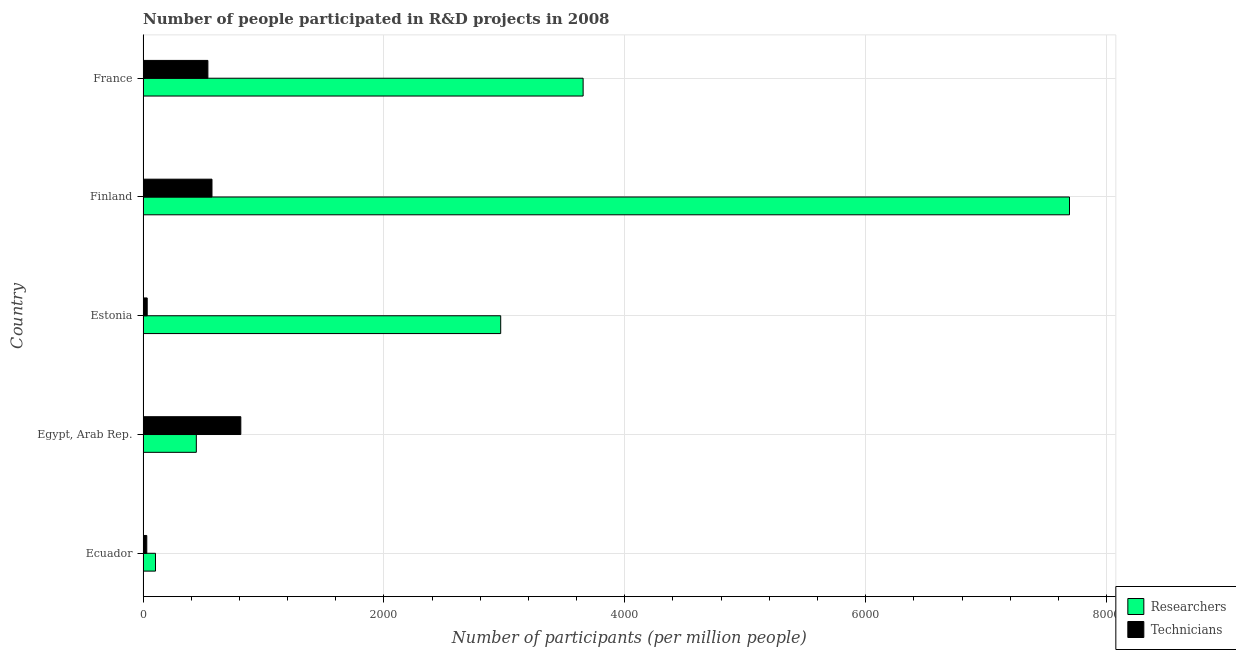How many groups of bars are there?
Give a very brief answer. 5. Are the number of bars on each tick of the Y-axis equal?
Ensure brevity in your answer.  Yes. How many bars are there on the 1st tick from the top?
Ensure brevity in your answer.  2. How many bars are there on the 2nd tick from the bottom?
Give a very brief answer. 2. What is the label of the 4th group of bars from the top?
Make the answer very short. Egypt, Arab Rep. What is the number of technicians in Finland?
Offer a terse response. 572.24. Across all countries, what is the maximum number of technicians?
Provide a short and direct response. 811.65. Across all countries, what is the minimum number of technicians?
Your answer should be compact. 30.85. In which country was the number of researchers minimum?
Your response must be concise. Ecuador. What is the total number of researchers in the graph?
Provide a succinct answer. 1.49e+04. What is the difference between the number of technicians in Egypt, Arab Rep. and that in Finland?
Give a very brief answer. 239.41. What is the difference between the number of technicians in Ecuador and the number of researchers in Finland?
Your answer should be compact. -7661.59. What is the average number of researchers per country?
Offer a terse response. 2972.29. What is the difference between the number of researchers and number of technicians in France?
Your answer should be compact. 3115.76. What is the ratio of the number of researchers in Estonia to that in Finland?
Offer a terse response. 0.39. Is the number of technicians in Egypt, Arab Rep. less than that in Finland?
Give a very brief answer. No. What is the difference between the highest and the second highest number of technicians?
Give a very brief answer. 239.41. What is the difference between the highest and the lowest number of technicians?
Offer a very short reply. 780.8. In how many countries, is the number of researchers greater than the average number of researchers taken over all countries?
Your answer should be very brief. 2. Is the sum of the number of technicians in Estonia and Finland greater than the maximum number of researchers across all countries?
Make the answer very short. No. What does the 1st bar from the top in France represents?
Ensure brevity in your answer.  Technicians. What does the 2nd bar from the bottom in Finland represents?
Your response must be concise. Technicians. Are all the bars in the graph horizontal?
Keep it short and to the point. Yes. What is the difference between two consecutive major ticks on the X-axis?
Make the answer very short. 2000. Are the values on the major ticks of X-axis written in scientific E-notation?
Keep it short and to the point. No. Does the graph contain grids?
Give a very brief answer. Yes. What is the title of the graph?
Provide a short and direct response. Number of people participated in R&D projects in 2008. What is the label or title of the X-axis?
Offer a very short reply. Number of participants (per million people). What is the Number of participants (per million people) in Researchers in Ecuador?
Your answer should be compact. 103.23. What is the Number of participants (per million people) of Technicians in Ecuador?
Make the answer very short. 30.85. What is the Number of participants (per million people) of Researchers in Egypt, Arab Rep.?
Your answer should be compact. 442.27. What is the Number of participants (per million people) in Technicians in Egypt, Arab Rep.?
Provide a succinct answer. 811.65. What is the Number of participants (per million people) in Researchers in Estonia?
Your response must be concise. 2969.53. What is the Number of participants (per million people) of Technicians in Estonia?
Offer a very short reply. 34.38. What is the Number of participants (per million people) in Researchers in Finland?
Keep it short and to the point. 7692.44. What is the Number of participants (per million people) of Technicians in Finland?
Offer a very short reply. 572.24. What is the Number of participants (per million people) in Researchers in France?
Your answer should be very brief. 3653.99. What is the Number of participants (per million people) of Technicians in France?
Your response must be concise. 538.23. Across all countries, what is the maximum Number of participants (per million people) in Researchers?
Your response must be concise. 7692.44. Across all countries, what is the maximum Number of participants (per million people) in Technicians?
Keep it short and to the point. 811.65. Across all countries, what is the minimum Number of participants (per million people) of Researchers?
Keep it short and to the point. 103.23. Across all countries, what is the minimum Number of participants (per million people) in Technicians?
Provide a succinct answer. 30.85. What is the total Number of participants (per million people) of Researchers in the graph?
Offer a very short reply. 1.49e+04. What is the total Number of participants (per million people) of Technicians in the graph?
Make the answer very short. 1987.34. What is the difference between the Number of participants (per million people) in Researchers in Ecuador and that in Egypt, Arab Rep.?
Provide a short and direct response. -339.04. What is the difference between the Number of participants (per million people) of Technicians in Ecuador and that in Egypt, Arab Rep.?
Ensure brevity in your answer.  -780.8. What is the difference between the Number of participants (per million people) of Researchers in Ecuador and that in Estonia?
Make the answer very short. -2866.3. What is the difference between the Number of participants (per million people) of Technicians in Ecuador and that in Estonia?
Ensure brevity in your answer.  -3.53. What is the difference between the Number of participants (per million people) of Researchers in Ecuador and that in Finland?
Ensure brevity in your answer.  -7589.21. What is the difference between the Number of participants (per million people) of Technicians in Ecuador and that in Finland?
Your answer should be very brief. -541.39. What is the difference between the Number of participants (per million people) in Researchers in Ecuador and that in France?
Provide a succinct answer. -3550.76. What is the difference between the Number of participants (per million people) in Technicians in Ecuador and that in France?
Offer a terse response. -507.38. What is the difference between the Number of participants (per million people) in Researchers in Egypt, Arab Rep. and that in Estonia?
Give a very brief answer. -2527.26. What is the difference between the Number of participants (per million people) of Technicians in Egypt, Arab Rep. and that in Estonia?
Your response must be concise. 777.27. What is the difference between the Number of participants (per million people) in Researchers in Egypt, Arab Rep. and that in Finland?
Your response must be concise. -7250.17. What is the difference between the Number of participants (per million people) of Technicians in Egypt, Arab Rep. and that in Finland?
Your response must be concise. 239.41. What is the difference between the Number of participants (per million people) in Researchers in Egypt, Arab Rep. and that in France?
Offer a terse response. -3211.72. What is the difference between the Number of participants (per million people) of Technicians in Egypt, Arab Rep. and that in France?
Make the answer very short. 273.42. What is the difference between the Number of participants (per million people) of Researchers in Estonia and that in Finland?
Give a very brief answer. -4722.91. What is the difference between the Number of participants (per million people) of Technicians in Estonia and that in Finland?
Ensure brevity in your answer.  -537.86. What is the difference between the Number of participants (per million people) in Researchers in Estonia and that in France?
Keep it short and to the point. -684.46. What is the difference between the Number of participants (per million people) in Technicians in Estonia and that in France?
Keep it short and to the point. -503.85. What is the difference between the Number of participants (per million people) of Researchers in Finland and that in France?
Offer a terse response. 4038.45. What is the difference between the Number of participants (per million people) of Technicians in Finland and that in France?
Your answer should be very brief. 34.01. What is the difference between the Number of participants (per million people) of Researchers in Ecuador and the Number of participants (per million people) of Technicians in Egypt, Arab Rep.?
Your response must be concise. -708.41. What is the difference between the Number of participants (per million people) of Researchers in Ecuador and the Number of participants (per million people) of Technicians in Estonia?
Make the answer very short. 68.86. What is the difference between the Number of participants (per million people) in Researchers in Ecuador and the Number of participants (per million people) in Technicians in Finland?
Keep it short and to the point. -469. What is the difference between the Number of participants (per million people) in Researchers in Ecuador and the Number of participants (per million people) in Technicians in France?
Your answer should be compact. -435. What is the difference between the Number of participants (per million people) in Researchers in Egypt, Arab Rep. and the Number of participants (per million people) in Technicians in Estonia?
Provide a succinct answer. 407.89. What is the difference between the Number of participants (per million people) of Researchers in Egypt, Arab Rep. and the Number of participants (per million people) of Technicians in Finland?
Ensure brevity in your answer.  -129.97. What is the difference between the Number of participants (per million people) in Researchers in Egypt, Arab Rep. and the Number of participants (per million people) in Technicians in France?
Your answer should be compact. -95.96. What is the difference between the Number of participants (per million people) of Researchers in Estonia and the Number of participants (per million people) of Technicians in Finland?
Provide a succinct answer. 2397.3. What is the difference between the Number of participants (per million people) in Researchers in Estonia and the Number of participants (per million people) in Technicians in France?
Offer a terse response. 2431.3. What is the difference between the Number of participants (per million people) of Researchers in Finland and the Number of participants (per million people) of Technicians in France?
Offer a terse response. 7154.21. What is the average Number of participants (per million people) in Researchers per country?
Provide a succinct answer. 2972.29. What is the average Number of participants (per million people) in Technicians per country?
Your response must be concise. 397.47. What is the difference between the Number of participants (per million people) in Researchers and Number of participants (per million people) in Technicians in Ecuador?
Offer a terse response. 72.38. What is the difference between the Number of participants (per million people) in Researchers and Number of participants (per million people) in Technicians in Egypt, Arab Rep.?
Provide a short and direct response. -369.38. What is the difference between the Number of participants (per million people) of Researchers and Number of participants (per million people) of Technicians in Estonia?
Give a very brief answer. 2935.16. What is the difference between the Number of participants (per million people) of Researchers and Number of participants (per million people) of Technicians in Finland?
Offer a very short reply. 7120.2. What is the difference between the Number of participants (per million people) in Researchers and Number of participants (per million people) in Technicians in France?
Offer a terse response. 3115.76. What is the ratio of the Number of participants (per million people) of Researchers in Ecuador to that in Egypt, Arab Rep.?
Ensure brevity in your answer.  0.23. What is the ratio of the Number of participants (per million people) of Technicians in Ecuador to that in Egypt, Arab Rep.?
Your answer should be very brief. 0.04. What is the ratio of the Number of participants (per million people) in Researchers in Ecuador to that in Estonia?
Give a very brief answer. 0.03. What is the ratio of the Number of participants (per million people) of Technicians in Ecuador to that in Estonia?
Offer a very short reply. 0.9. What is the ratio of the Number of participants (per million people) in Researchers in Ecuador to that in Finland?
Your response must be concise. 0.01. What is the ratio of the Number of participants (per million people) of Technicians in Ecuador to that in Finland?
Ensure brevity in your answer.  0.05. What is the ratio of the Number of participants (per million people) of Researchers in Ecuador to that in France?
Your answer should be compact. 0.03. What is the ratio of the Number of participants (per million people) in Technicians in Ecuador to that in France?
Provide a succinct answer. 0.06. What is the ratio of the Number of participants (per million people) in Researchers in Egypt, Arab Rep. to that in Estonia?
Offer a terse response. 0.15. What is the ratio of the Number of participants (per million people) in Technicians in Egypt, Arab Rep. to that in Estonia?
Your answer should be very brief. 23.61. What is the ratio of the Number of participants (per million people) of Researchers in Egypt, Arab Rep. to that in Finland?
Give a very brief answer. 0.06. What is the ratio of the Number of participants (per million people) in Technicians in Egypt, Arab Rep. to that in Finland?
Your response must be concise. 1.42. What is the ratio of the Number of participants (per million people) in Researchers in Egypt, Arab Rep. to that in France?
Give a very brief answer. 0.12. What is the ratio of the Number of participants (per million people) in Technicians in Egypt, Arab Rep. to that in France?
Offer a very short reply. 1.51. What is the ratio of the Number of participants (per million people) of Researchers in Estonia to that in Finland?
Offer a very short reply. 0.39. What is the ratio of the Number of participants (per million people) in Technicians in Estonia to that in Finland?
Offer a very short reply. 0.06. What is the ratio of the Number of participants (per million people) of Researchers in Estonia to that in France?
Make the answer very short. 0.81. What is the ratio of the Number of participants (per million people) in Technicians in Estonia to that in France?
Your answer should be very brief. 0.06. What is the ratio of the Number of participants (per million people) in Researchers in Finland to that in France?
Your answer should be compact. 2.11. What is the ratio of the Number of participants (per million people) in Technicians in Finland to that in France?
Offer a terse response. 1.06. What is the difference between the highest and the second highest Number of participants (per million people) in Researchers?
Provide a succinct answer. 4038.45. What is the difference between the highest and the second highest Number of participants (per million people) of Technicians?
Give a very brief answer. 239.41. What is the difference between the highest and the lowest Number of participants (per million people) in Researchers?
Make the answer very short. 7589.21. What is the difference between the highest and the lowest Number of participants (per million people) in Technicians?
Offer a very short reply. 780.8. 